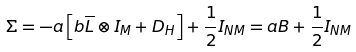Convert formula to latex. <formula><loc_0><loc_0><loc_500><loc_500>\Sigma = - a \left [ b \overline { L } \otimes I _ { M } + D _ { H } \right ] + \frac { 1 } { 2 } I _ { N M } = a B + \frac { 1 } { 2 } I _ { N M }</formula> 